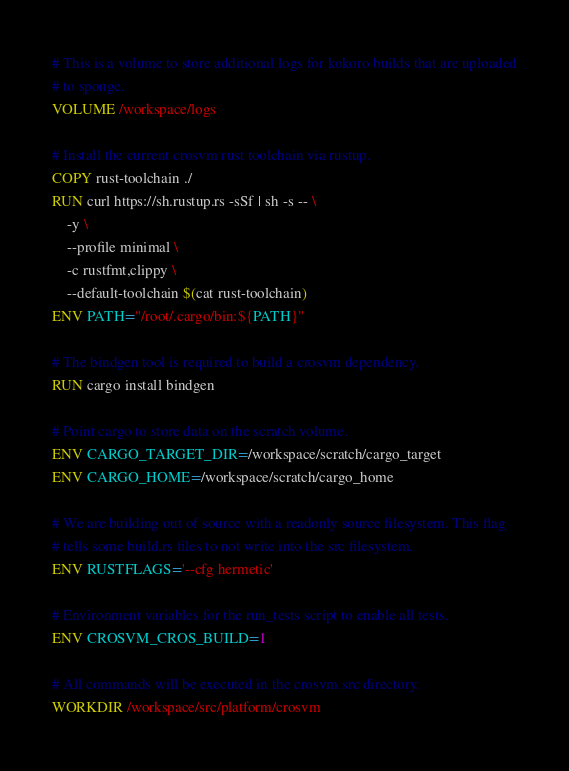Convert code to text. <code><loc_0><loc_0><loc_500><loc_500><_Dockerfile_># This is a volume to store additional logs for kokoro builds that are uploaded
# to sponge.
VOLUME /workspace/logs

# Install the current crosvm rust toolchain via rustup.
COPY rust-toolchain ./
RUN curl https://sh.rustup.rs -sSf | sh -s -- \
    -y \
    --profile minimal \
    -c rustfmt,clippy \
    --default-toolchain $(cat rust-toolchain)
ENV PATH="/root/.cargo/bin:${PATH}"

# The bindgen tool is required to build a crosvm dependency.
RUN cargo install bindgen

# Point cargo to store data on the scratch volume.
ENV CARGO_TARGET_DIR=/workspace/scratch/cargo_target
ENV CARGO_HOME=/workspace/scratch/cargo_home

# We are building out of source with a readonly source filesystem. This flag
# tells some build.rs files to not write into the src filesystem.
ENV RUSTFLAGS='--cfg hermetic'

# Environment variables for the run_tests script to enable all tests.
ENV CROSVM_CROS_BUILD=1

# All commands will be executed in the crosvm src directory.
WORKDIR /workspace/src/platform/crosvm
</code> 